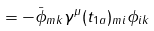<formula> <loc_0><loc_0><loc_500><loc_500>= - \bar { \phi } _ { m k } \gamma ^ { \mu } ( t _ { 1 a } ) _ { m i } \phi _ { i k }</formula> 